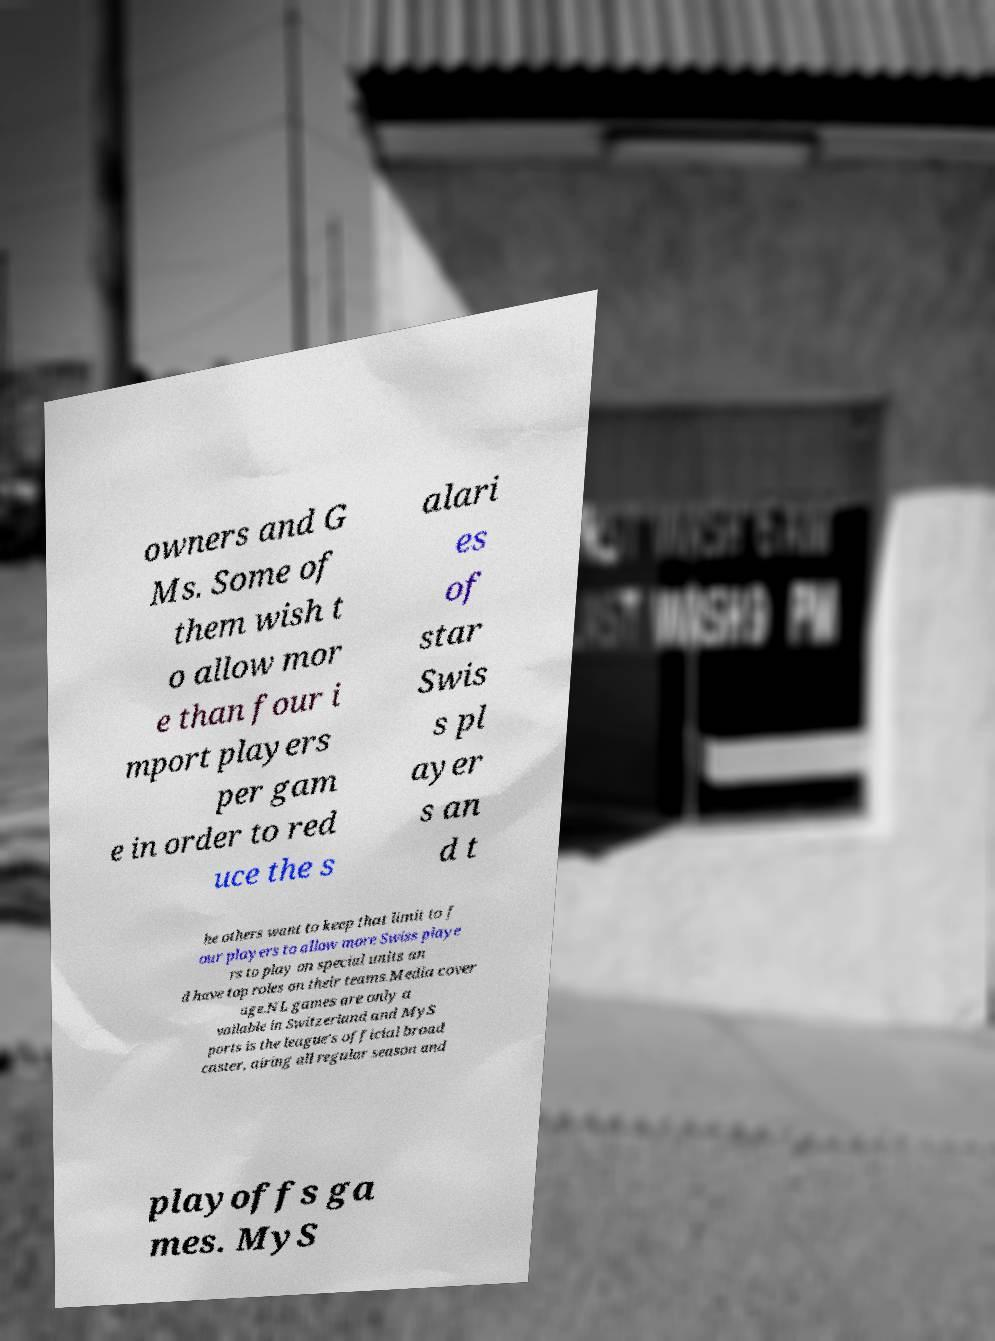Please read and relay the text visible in this image. What does it say? owners and G Ms. Some of them wish t o allow mor e than four i mport players per gam e in order to red uce the s alari es of star Swis s pl ayer s an d t he others want to keep that limit to f our players to allow more Swiss playe rs to play on special units an d have top roles on their teams.Media cover age.NL games are only a vailable in Switzerland and MyS ports is the league's official broad caster, airing all regular season and playoffs ga mes. MyS 